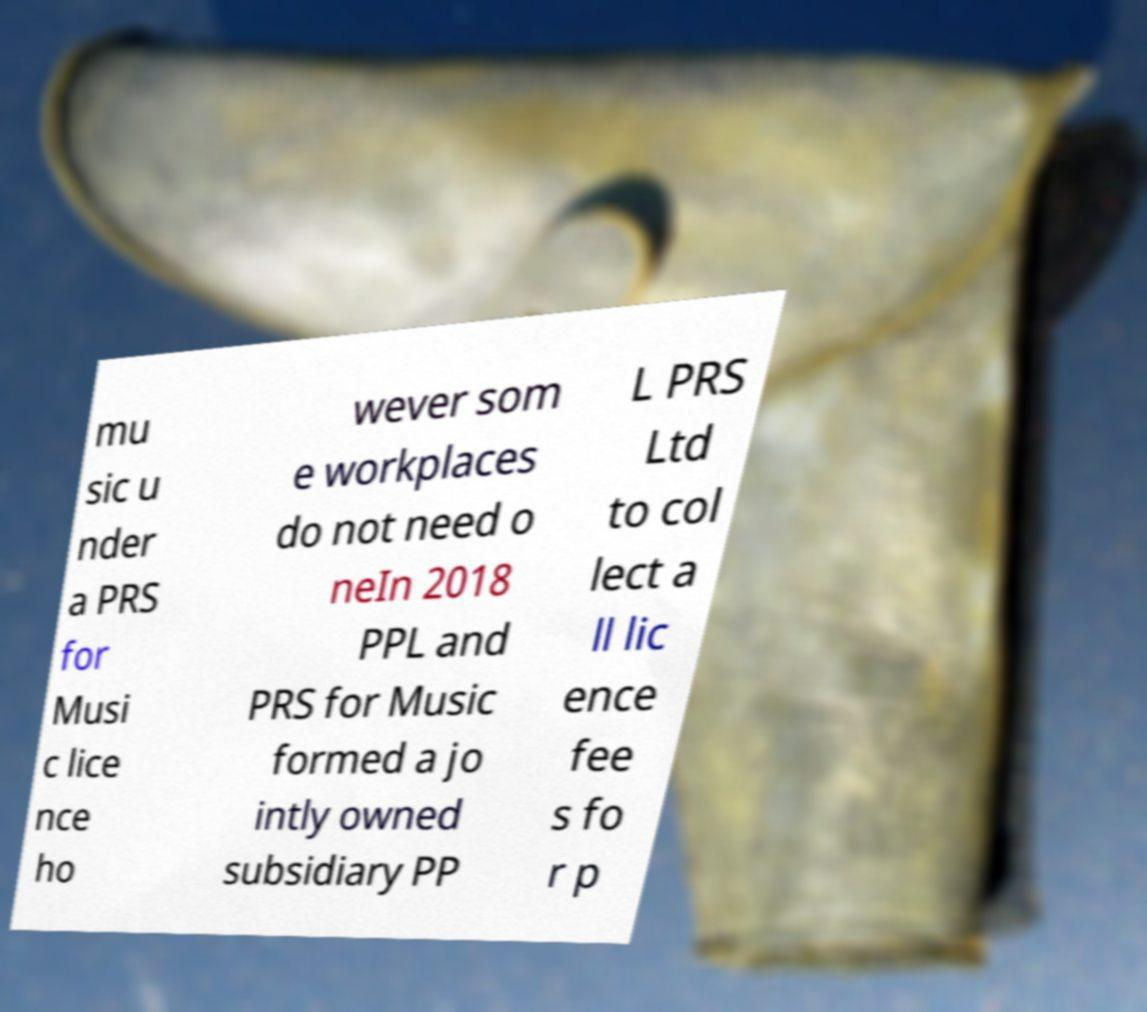I need the written content from this picture converted into text. Can you do that? mu sic u nder a PRS for Musi c lice nce ho wever som e workplaces do not need o neIn 2018 PPL and PRS for Music formed a jo intly owned subsidiary PP L PRS Ltd to col lect a ll lic ence fee s fo r p 